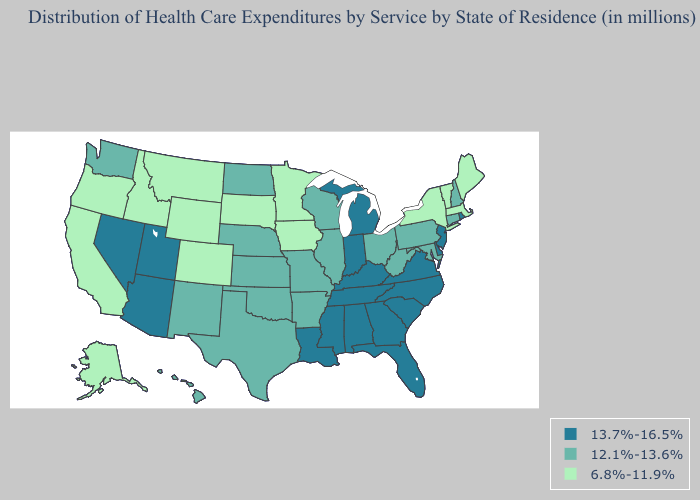How many symbols are there in the legend?
Short answer required. 3. Does New Jersey have the highest value in the Northeast?
Answer briefly. Yes. What is the highest value in the West ?
Write a very short answer. 13.7%-16.5%. Does Michigan have the highest value in the USA?
Write a very short answer. Yes. What is the highest value in the West ?
Short answer required. 13.7%-16.5%. Among the states that border North Dakota , which have the highest value?
Answer briefly. Minnesota, Montana, South Dakota. What is the lowest value in the USA?
Short answer required. 6.8%-11.9%. Among the states that border Nevada , which have the lowest value?
Answer briefly. California, Idaho, Oregon. Name the states that have a value in the range 6.8%-11.9%?
Keep it brief. Alaska, California, Colorado, Idaho, Iowa, Maine, Massachusetts, Minnesota, Montana, New York, Oregon, South Dakota, Vermont, Wyoming. Name the states that have a value in the range 13.7%-16.5%?
Give a very brief answer. Alabama, Arizona, Delaware, Florida, Georgia, Indiana, Kentucky, Louisiana, Michigan, Mississippi, Nevada, New Jersey, North Carolina, Rhode Island, South Carolina, Tennessee, Utah, Virginia. Name the states that have a value in the range 13.7%-16.5%?
Be succinct. Alabama, Arizona, Delaware, Florida, Georgia, Indiana, Kentucky, Louisiana, Michigan, Mississippi, Nevada, New Jersey, North Carolina, Rhode Island, South Carolina, Tennessee, Utah, Virginia. What is the highest value in the USA?
Give a very brief answer. 13.7%-16.5%. Is the legend a continuous bar?
Short answer required. No. Among the states that border Idaho , does Utah have the lowest value?
Answer briefly. No. 